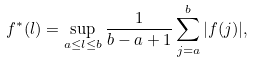Convert formula to latex. <formula><loc_0><loc_0><loc_500><loc_500>f ^ { * } ( l ) = \sup _ { a \leq l \leq b } \frac { 1 } { b - a + 1 } \sum _ { j = a } ^ { b } | f ( j ) | ,</formula> 